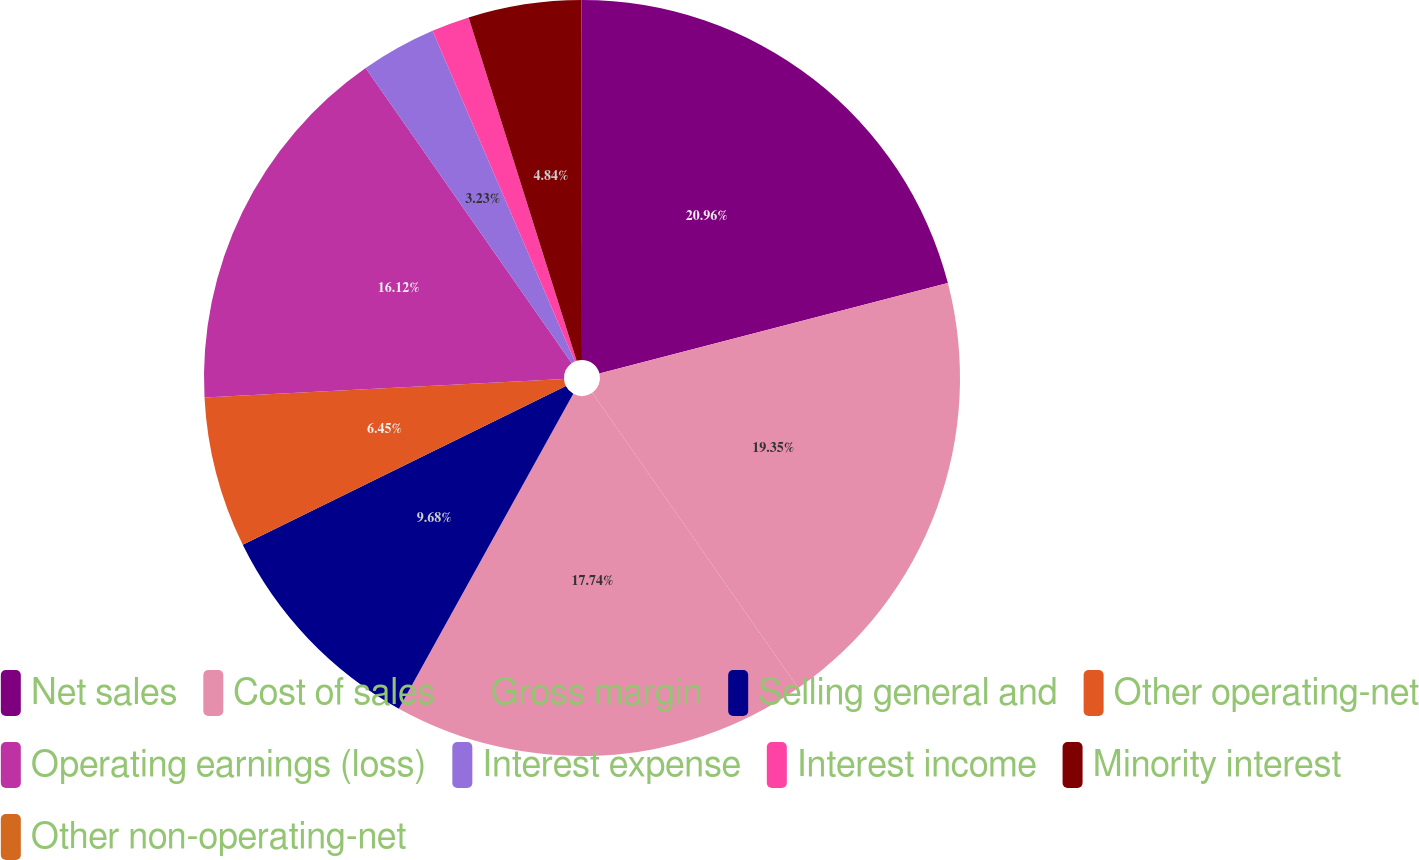Convert chart to OTSL. <chart><loc_0><loc_0><loc_500><loc_500><pie_chart><fcel>Net sales<fcel>Cost of sales<fcel>Gross margin<fcel>Selling general and<fcel>Other operating-net<fcel>Operating earnings (loss)<fcel>Interest expense<fcel>Interest income<fcel>Minority interest<fcel>Other non-operating-net<nl><fcel>20.96%<fcel>19.35%<fcel>17.74%<fcel>9.68%<fcel>6.45%<fcel>16.12%<fcel>3.23%<fcel>1.62%<fcel>4.84%<fcel>0.01%<nl></chart> 